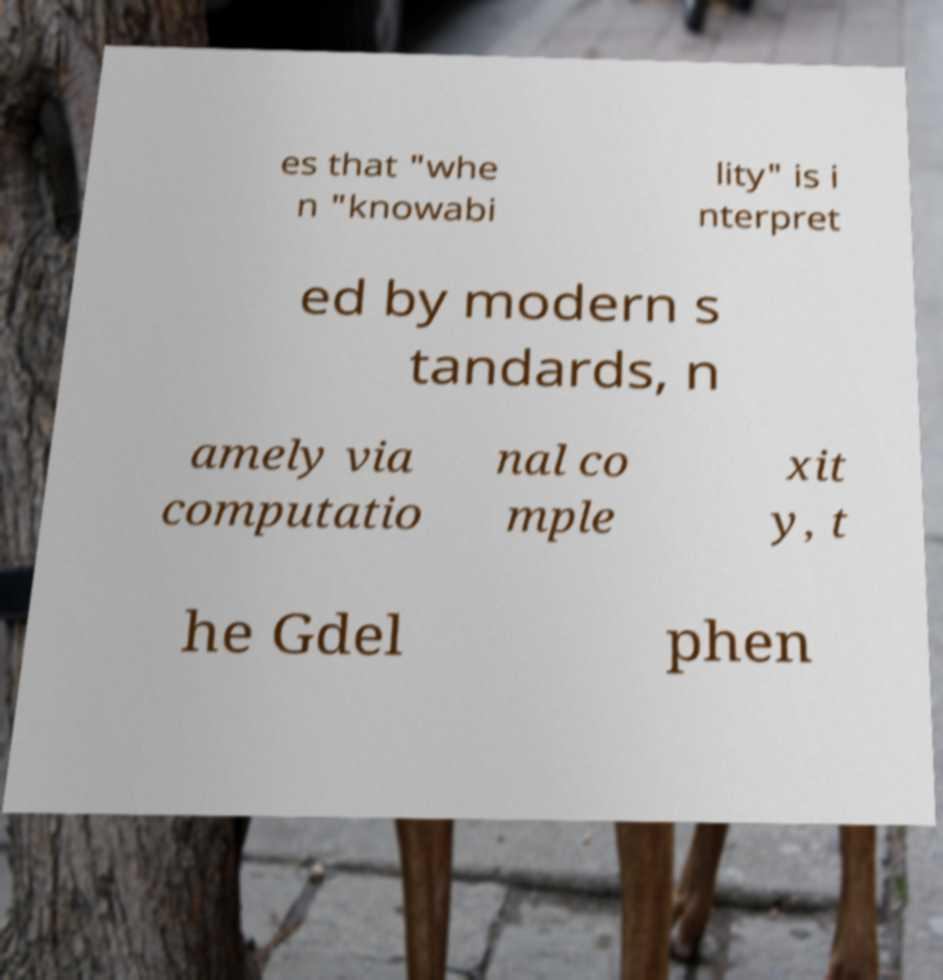Can you accurately transcribe the text from the provided image for me? es that "whe n "knowabi lity" is i nterpret ed by modern s tandards, n amely via computatio nal co mple xit y, t he Gdel phen 